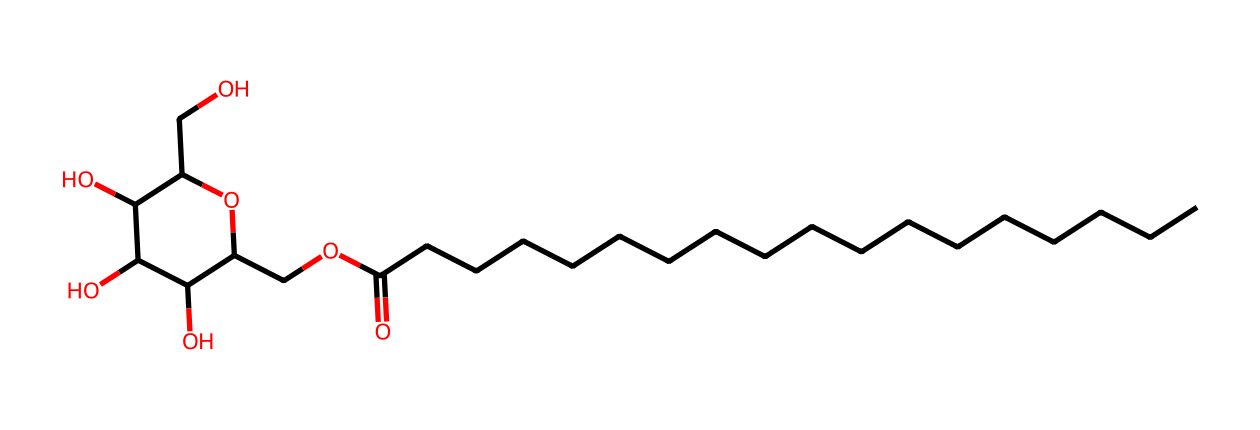What is the primary function of sorbitan monostearate in food products? Sorbitan monostearate functions primarily as an emulsifier, which helps mix water and oil in food formulations and improves the texture.
Answer: emulsifier How many carbon atoms are present in sorbitan monostearate? By analyzing the SMILES representation, we can count 21 carbon atoms in total (C).
Answer: 21 What is the hydrophilic part of sorbitan monostearate? The hydrophilic part is the sugar alcohol moiety, which consists of hydroxyl (–OH) groups, contributing to the solubility in water.
Answer: sugar alcohol How many fatty acid chains does sorbitan monostearate contain? The structure shows a single fatty acid chain linked through an ester bond, indicating it has one fatty acid.
Answer: one What type of surfactant is sorbitan monostearate classified as? Sorbitan monostearate is classified as a non-ionic surfactant due to the absence of ionizable groups in its structure.
Answer: non-ionic Which functional group is responsible for the emulsifying properties of sorbitan monostearate? The ester functional group (–COO–) links the fatty acid to the sugar alcohol and is crucial for its emulsifying properties.
Answer: ester Does sorbitan monostearate have any hydroxyl groups? Yes, the structure includes multiple hydroxyl (–OH) groups, which contribute to its hydrophilic character.
Answer: yes 